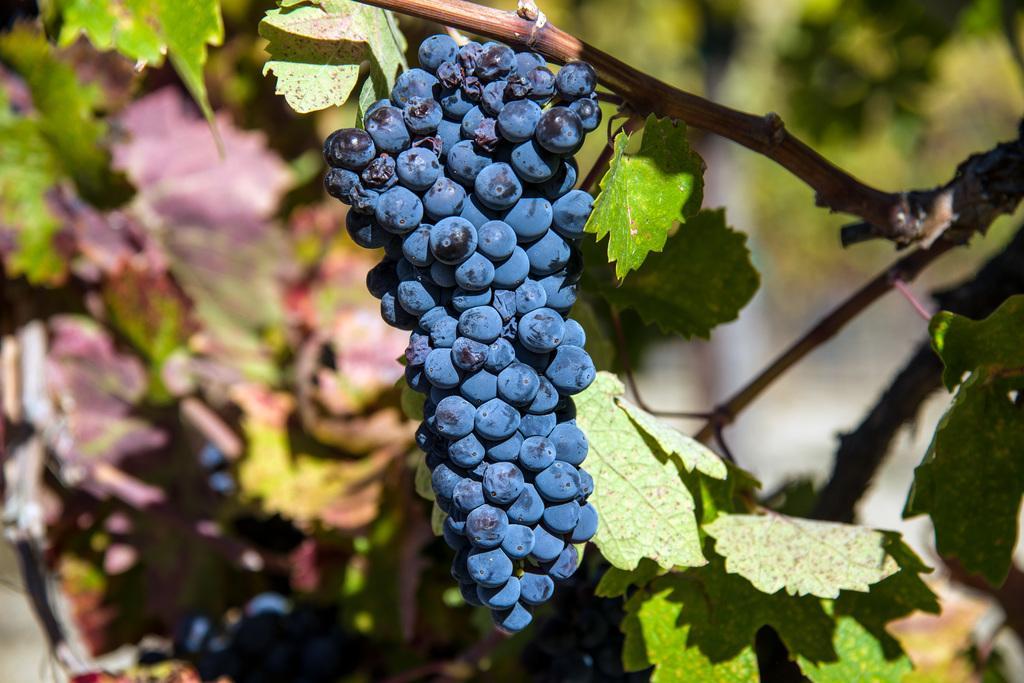Could you give a brief overview of what you see in this image? This image is taken outdoors. In this image there is a grape plant with green leaves, stems and grapes. 